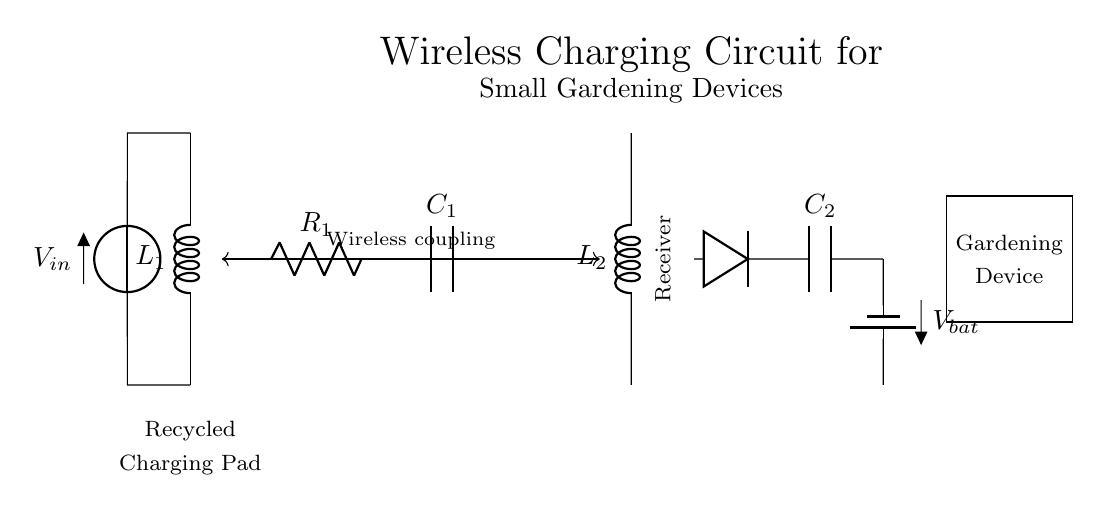What type of components are used in this circuit? The circuit uses a wireless charging coil, a resistor, a capacitor, a diode, and a battery. Each component's label indicates its function and connection in the circuit.
Answer: wireless charging coil, resistor, capacitor, diode, battery What is the role of the rectifier in this circuit? The rectifier converts the alternating current produced by the wireless charging coil into direct current, which is necessary for charging the battery. The diode's placement in the circuit shows its function as a rectifying device.
Answer: converts AC to DC How many capacitors are present in the diagram? There are two capacitors labeled as C1 and C2 used in the circuit. Identifying the labels in the diagram allows us to count the capacitors present.
Answer: two What connects the charging pad to the gardening device? The wireless coupling connects the charging pad to the gardening device, as indicated by the double-headed arrow showing the interaction between the two parts of the circuit.
Answer: wireless coupling What is the voltage of the battery in this circuit? The battery is labeled as V bat, which signifies its voltage level; however, the exact value is not specified in the diagram. All information regarding the battery is presented through its symbol and context.
Answer: V bat How do the components interact to enable charging? The charging process begins with the wireless charging coil generating an alternating current, which is then passed through the rectifier (diode) to convert it into direct current, charging the battery, and powering the gardening device. This interaction highlights the charging mechanism and flow of energy within the circuit.
Answer: through wireless coupling and rectification 